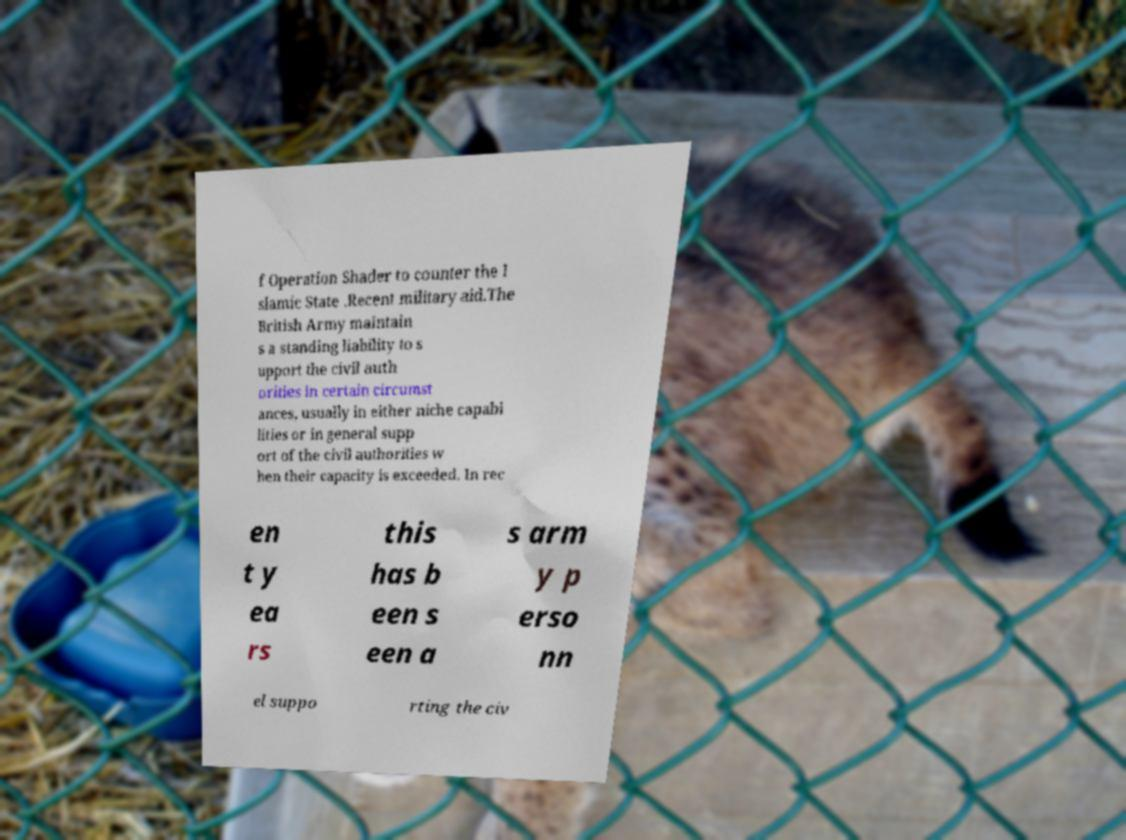Could you extract and type out the text from this image? f Operation Shader to counter the I slamic State .Recent military aid.The British Army maintain s a standing liability to s upport the civil auth orities in certain circumst ances, usually in either niche capabi lities or in general supp ort of the civil authorities w hen their capacity is exceeded. In rec en t y ea rs this has b een s een a s arm y p erso nn el suppo rting the civ 